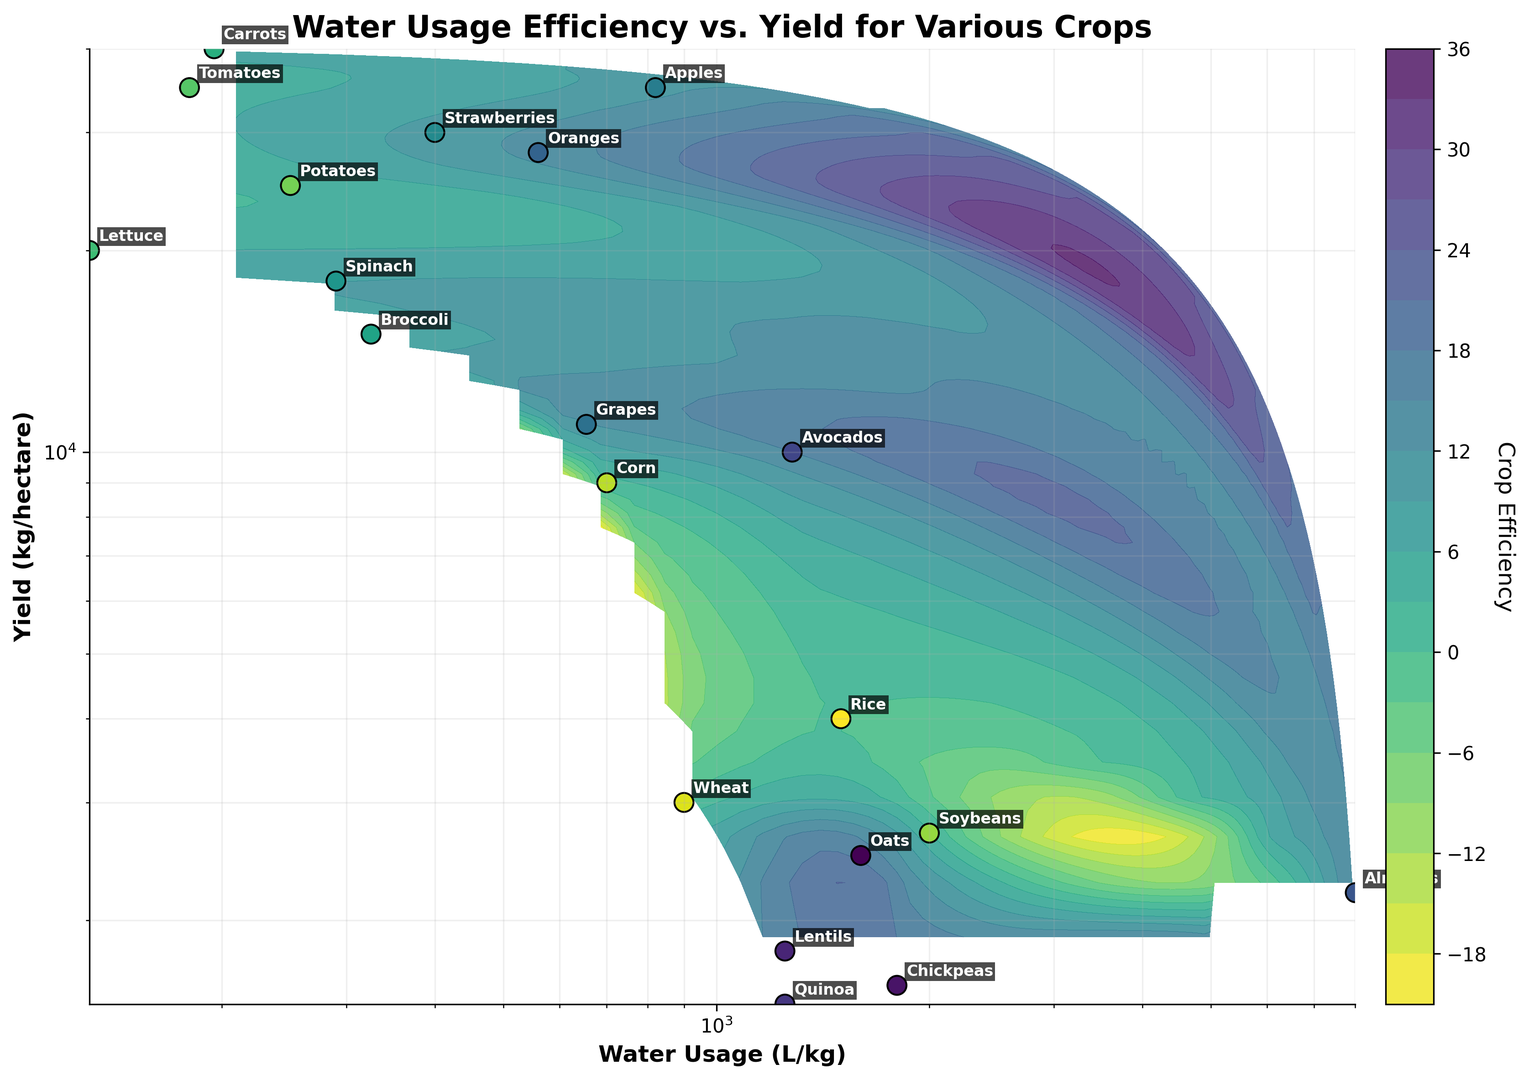What crop has the highest water usage per kilogram? Look for the crop with the highest value on the x-axis.
Answer: Almonds What crop has the highest yield per hectare? Look for the crop with the highest value on the y-axis.
Answer: Carrots Which crop has both high yield and low water usage, according to the figure? Cross-reference values on both axes to find crops with high y-values and low x-values.
Answer: Tomatoes How does the water usage of rice compare to wheat? Identify the x-values for both rice and wheat and compare them.
Answer: Rice uses more water than wheat What is the difference in yield per hectare between lettuce and spinach? Determine the y-values for both lettuce and spinach and subtract one from the other.
Answer: 2,000 kg/hectare Which crop has a relatively low yield but very high water usage? Look for crops with low y-values and high x-values.
Answer: Almonds Is there a crop that lies in the middle for both water usage and yield? Identify crops around the middle of both axes (logarithmic scales).
Answer: Apples Between broccoli and grapes, which one requires less water per kilogram? Compare the x-values for broccoli and grapes.
Answer: Grapes What is the average water usage per kilogram for tomatoes, lettuce, and carrots? Add the x-values for tomatoes, lettuce, and carrots and divide by 3.
Answer: 168.33 L/kg How does the yield of avocados compare to oranges? Identify and compare the y-values for avocados and oranges.
Answer: Oranges have a higher yield than avocados 